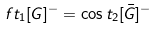<formula> <loc_0><loc_0><loc_500><loc_500>\ f t _ { 1 } [ G ] ^ { - } = \cos t _ { 2 } [ \bar { G } ] ^ { - }</formula> 